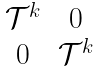<formula> <loc_0><loc_0><loc_500><loc_500>\begin{matrix} \mathcal { T } ^ { k } & 0 \\ 0 & \mathcal { T } ^ { k } \end{matrix}</formula> 